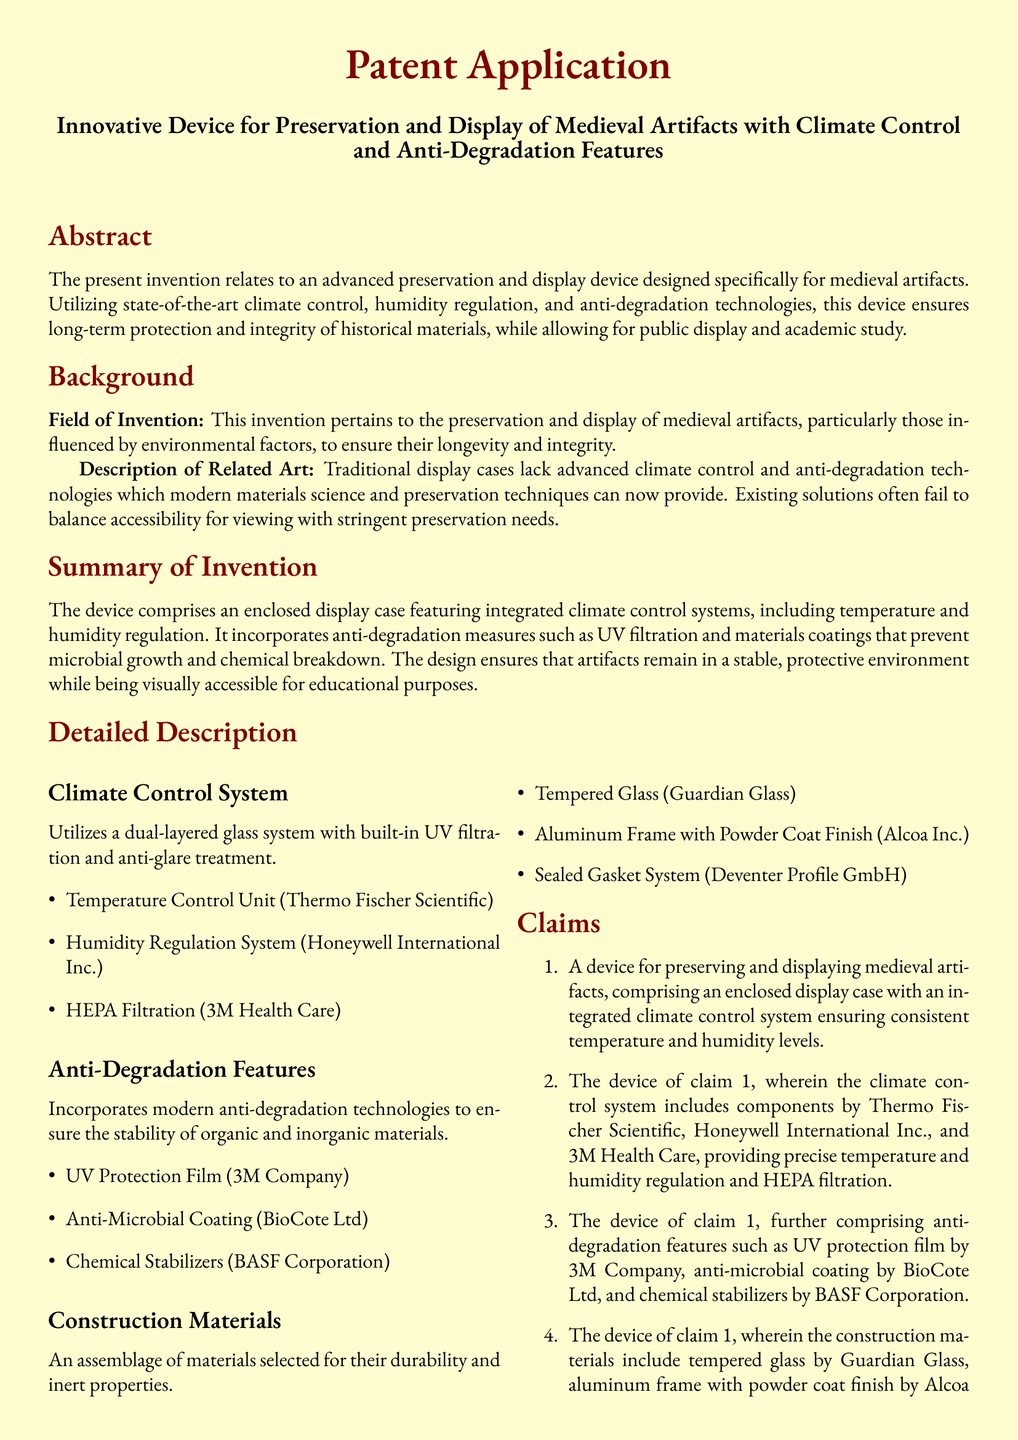What is the field of invention? The field of invention is specifically focused on the preservation and display of medieval artifacts influenced by environmental factors.
Answer: preservation and display of medieval artifacts What does the device use for climate control? The document specifies that the device uses a climate control system which includes components by Thermo Fischer Scientific, Honeywell International Inc., and 3M Health Care.
Answer: integrated climate control system Which company provides the UV Protection Film? The document lists the 3M Company as the provider of the UV Protection Film.
Answer: 3M Company What is one application of the device? The document states that the device can be applied in museums specialized in medieval history.
Answer: museums specialized in medieval history What material is the frame made from? According to the document, the frame is made from aluminum with a powder coat finish.
Answer: aluminum frame with powder coat finish How many claims are there in the patent application? The document enumerates four claims related to the device.
Answer: four What is one anti-degradation feature of the device? The patent application mentions an anti-microbial coating provided by BioCote Ltd as an anti-degradation feature.
Answer: anti-microbial coating What type of glass is used in construction? The document specifies that tempered glass from Guardian Glass is used in the construction of the device.
Answer: tempered glass What does the construction materials section focus on? This section emphasizes aspects such as durability and inert properties in the selected materials for the device.
Answer: durability and inert properties 